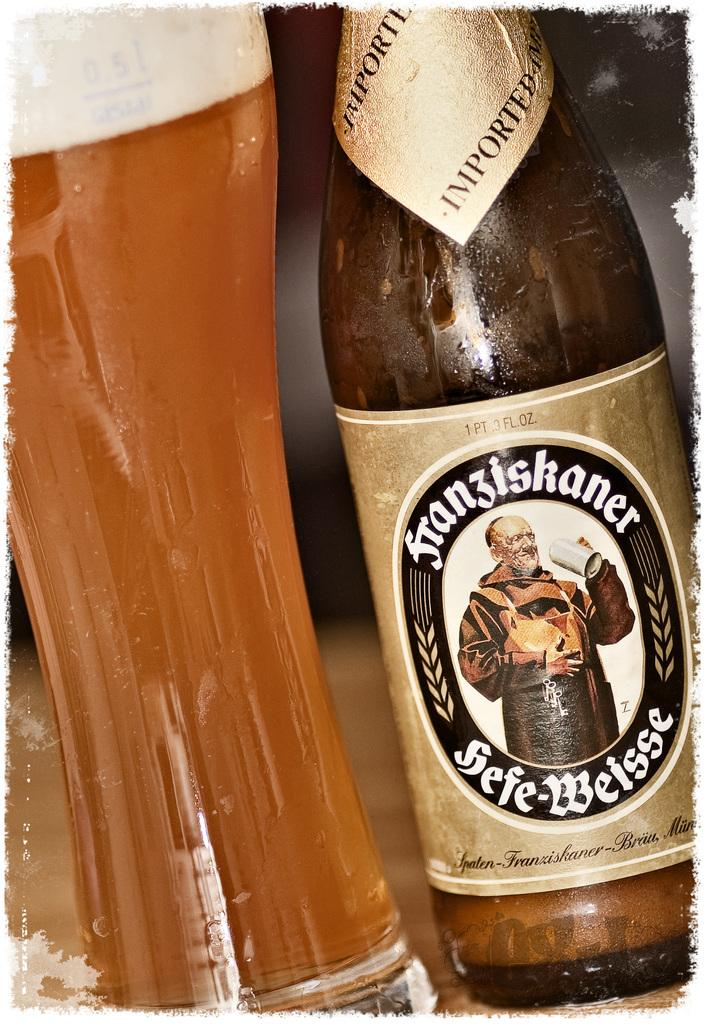<image>
Describe the image concisely. A bottle of Franziskaner beer sits next to a full glass. 